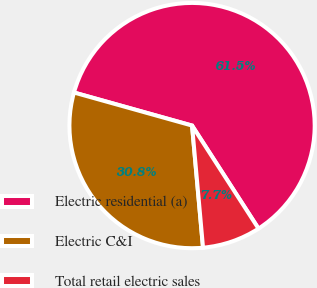<chart> <loc_0><loc_0><loc_500><loc_500><pie_chart><fcel>Electric residential (a)<fcel>Electric C&I<fcel>Total retail electric sales<nl><fcel>61.54%<fcel>30.77%<fcel>7.69%<nl></chart> 